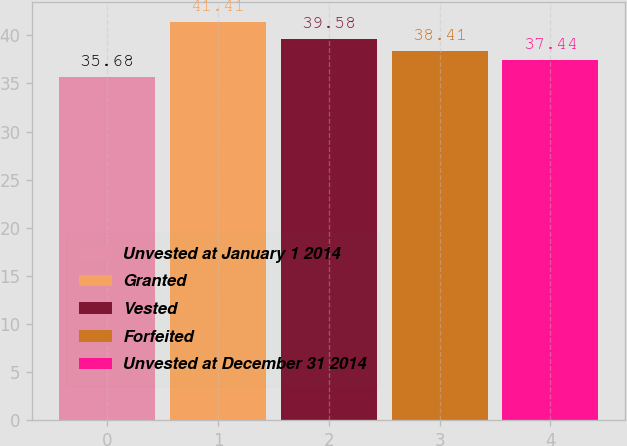<chart> <loc_0><loc_0><loc_500><loc_500><bar_chart><fcel>Unvested at January 1 2014<fcel>Granted<fcel>Vested<fcel>Forfeited<fcel>Unvested at December 31 2014<nl><fcel>35.68<fcel>41.41<fcel>39.58<fcel>38.41<fcel>37.44<nl></chart> 